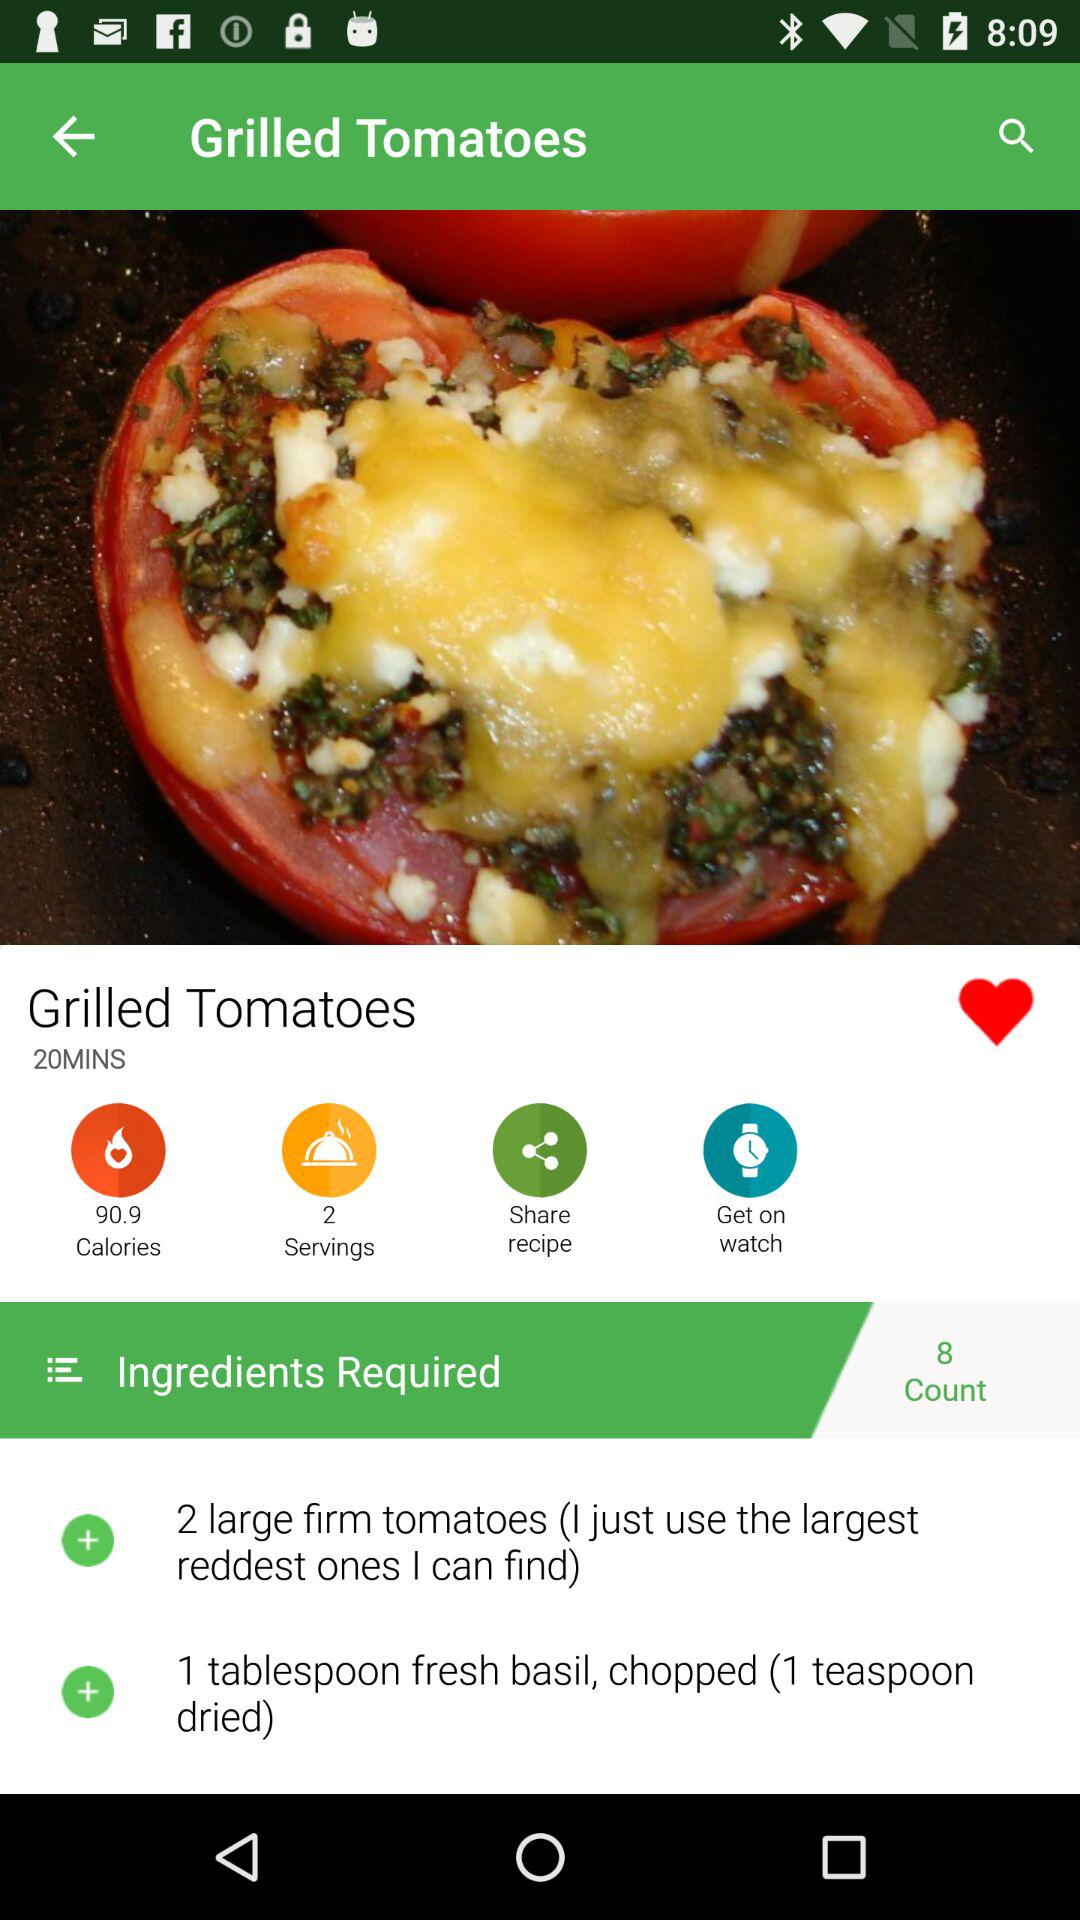How many ingredients are in this recipe?
Answer the question using a single word or phrase. 2 